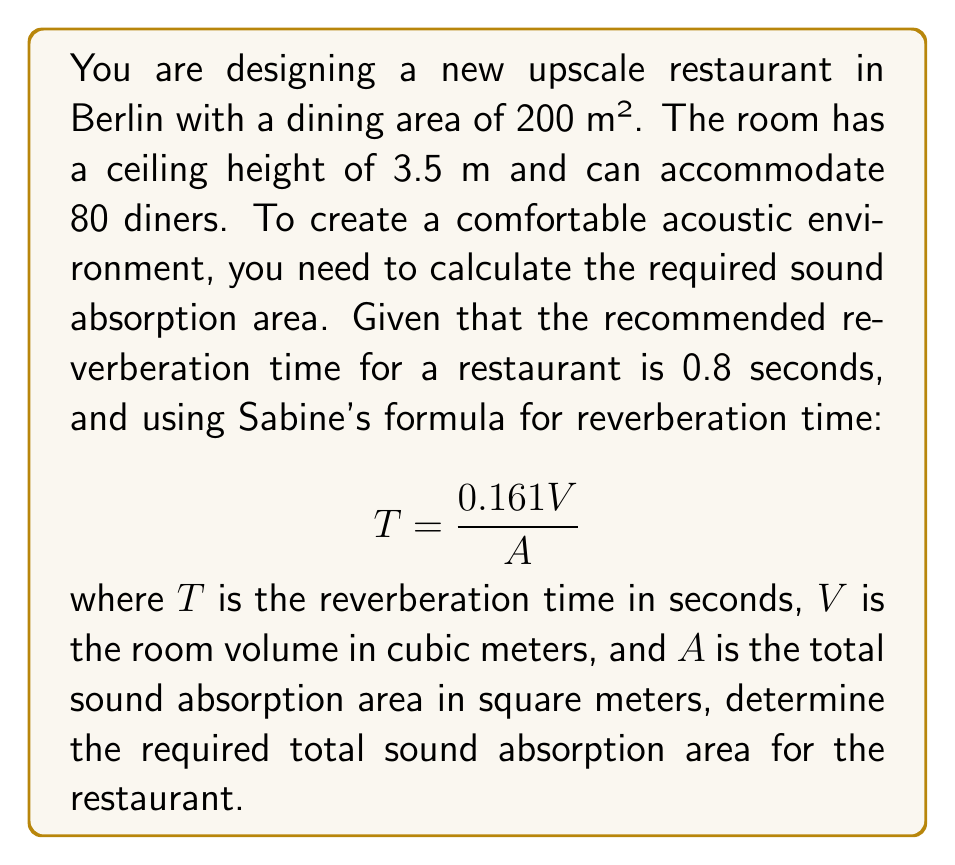What is the answer to this math problem? To solve this problem, we'll follow these steps:

1. Calculate the room volume:
   $V = \text{floor area} \times \text{ceiling height}$
   $V = 200 \text{ m}^2 \times 3.5 \text{ m} = 700 \text{ m}^3$

2. Rearrange Sabine's formula to solve for $A$:
   $$ T = \frac{0.161V}{A} $$
   $$ A = \frac{0.161V}{T} $$

3. Substitute the known values:
   $T = 0.8 \text{ seconds}$ (recommended reverberation time)
   $V = 700 \text{ m}^3$ (calculated in step 1)

4. Calculate the required total sound absorption area:
   $$ A = \frac{0.161 \times 700}{0.8} $$
   $$ A = \frac{112.7}{0.8} $$
   $$ A = 140.875 \text{ m}^2 $$

Therefore, the required total sound absorption area for the restaurant is approximately 140.875 square meters.
Answer: The required total sound absorption area for the restaurant is 140.875 m². 